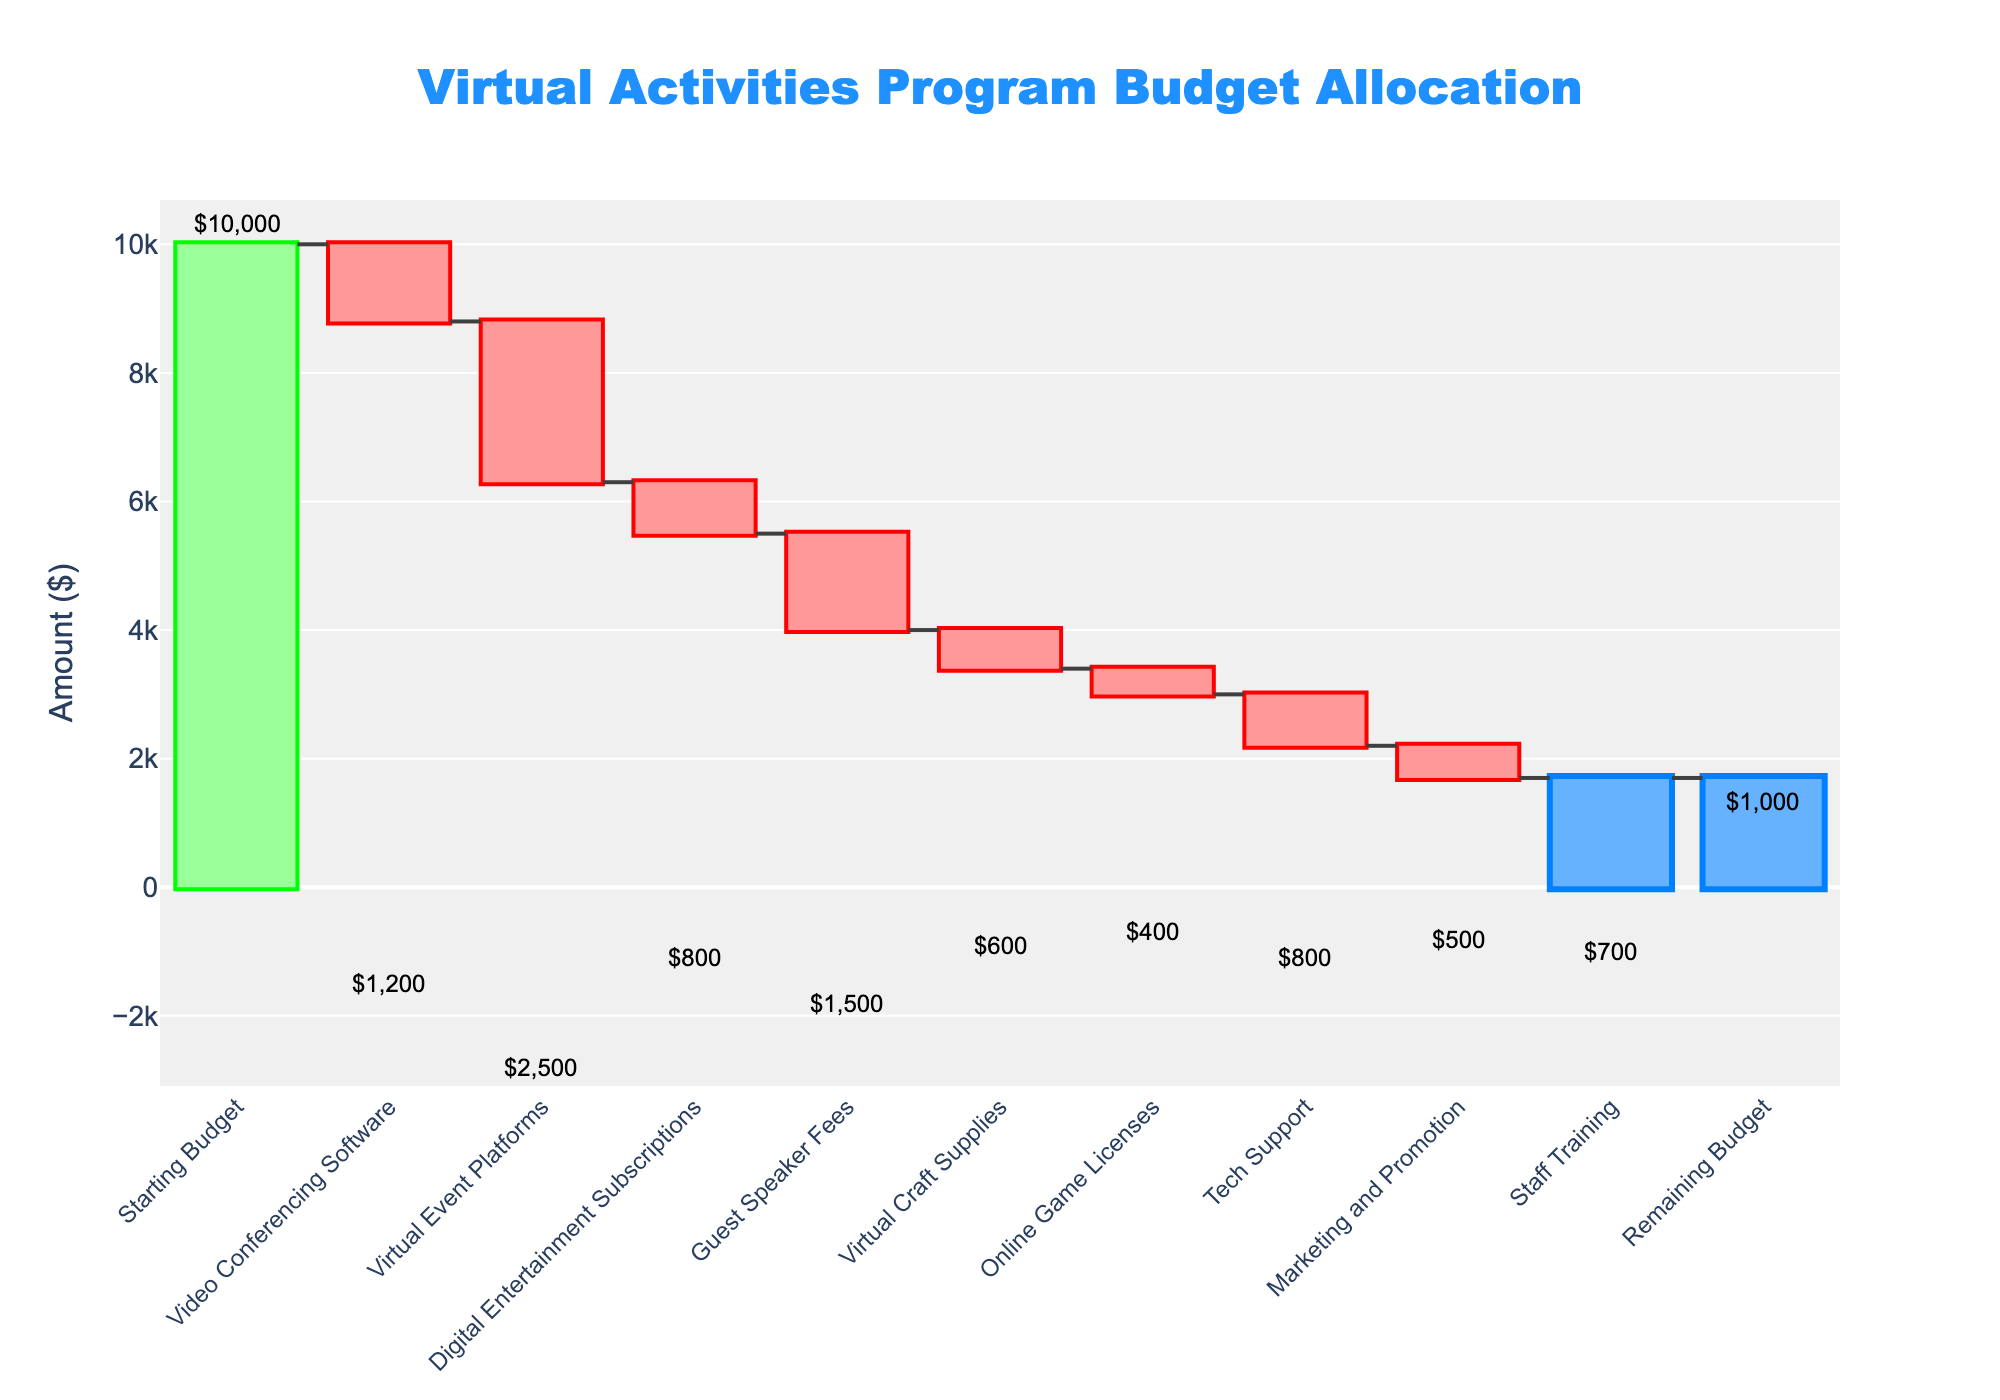What's the starting budget for the virtual activities program? The starting budget is directly labeled as "Starting Budget" on the chart. Its corresponding value is clearly visible at the top of the bar.
Answer: $10,000 How much is spent on video conferencing software? "Video Conferencing Software" is labeled on the chart with a negative amount, indicating spending. The value can be read directly from the chart.
Answer: $1,200 What is the total amount spent on guest speaker fees and virtual craft supplies? To find the total amount spent on Guest Speaker Fees and Virtual Craft Supplies, add their corresponding values: $1,500 (Guest Speaker Fees) + $600 (Virtual Craft Supplies).
Answer: $2,100 Which category has the smallest expense? Reviewing the labels and the lengths/colors of the bars, "Online Game Licenses" has the smallest negative value, indicating the smallest expense.
Answer: Online Game Licenses What’s the remaining budget after all expenses? The chart shows "Remaining Budget" with a specific value at the end. This can be read directly from the figure.
Answer: $1,000 Which category has the highest expense? From observing the lengths of the negative bars, "Virtual Event Platforms" has the longest negative bar, indicating the highest expense.
Answer: Virtual Event Platforms How much was spent on marketing and promotion relative to tech support? Look at the negative values and compare: Marketing and Promotion is $500, and Tech Support is $800. Since 500 < 800, less was spent on marketing and promotion. The absolute values confirm this difference.
Answer: $300 less If the budget for digital entertainment subscriptions was doubled, how would the total expenses change? Doubling the Digital Entertainment Subscriptions would mean $800 * 2 = $1,600. The difference from original spending is $1,600 - $800 = $800. Adding this extra $800 to the current total expenses impacts the overall remaining budget.
Answer: Additional $800 in expenses Calculate the percentage of the starting budget spent on staff training. First, find the amount spent on Staff Training ($700). Then, divide this by the starting budget ($10,000) and multiply by 100 to get the percentage: ($700 / $10,000) * 100 = 7%.
Answer: 7% How do the expenditures on virtual craft supplies and tech support compare? Comparing the negative values directly shows that Tech Support (-$800) is greater than Virtual Craft Supplies (-$600). This indicates more was spent on Tech Support than Virtual Craft Supplies.
Answer: Tech Support has a higher expense than Virtual Craft Supplies 